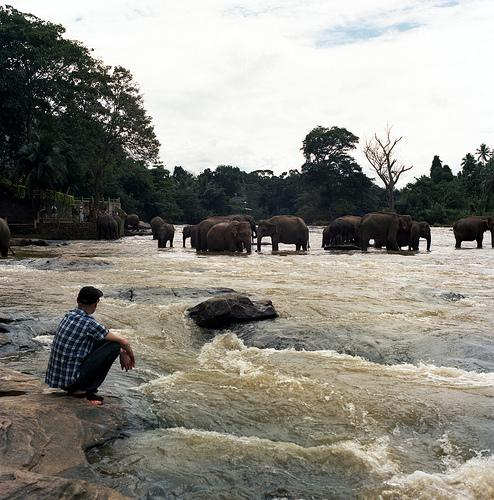Question: what animal is in the picture?
Choices:
A. Zebra.
B. Elephant.
C. Giraffe.
D. Lion.
Answer with the letter. Answer: B Question: where are the elephants?
Choices:
A. A plain.
B. A zoo.
C. By a fence.
D. In water.
Answer with the letter. Answer: D Question: where is the man?
Choices:
A. On a tree stump.
B. By a gate.
C. By a tree.
D. On the rock.
Answer with the letter. Answer: D Question: what is the man doing?
Choices:
A. Fishing.
B. Reading.
C. Crying.
D. Watching the elephants.
Answer with the letter. Answer: D Question: what is in the background?
Choices:
A. Trees.
B. Plants.
C. Sunflowers.
D. A fence.
Answer with the letter. Answer: A Question: where are the man's arms?
Choices:
A. Around the child.
B. Behind his head.
C. Over his knees.
D. Around a woman.
Answer with the letter. Answer: C 